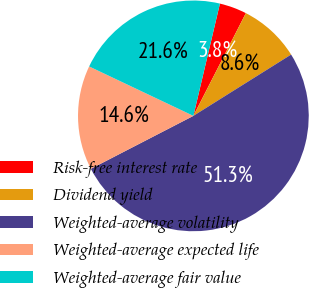<chart> <loc_0><loc_0><loc_500><loc_500><pie_chart><fcel>Risk-free interest rate<fcel>Dividend yield<fcel>Weighted-average volatility<fcel>Weighted-average expected life<fcel>Weighted-average fair value<nl><fcel>3.82%<fcel>8.57%<fcel>51.33%<fcel>14.63%<fcel>21.65%<nl></chart> 